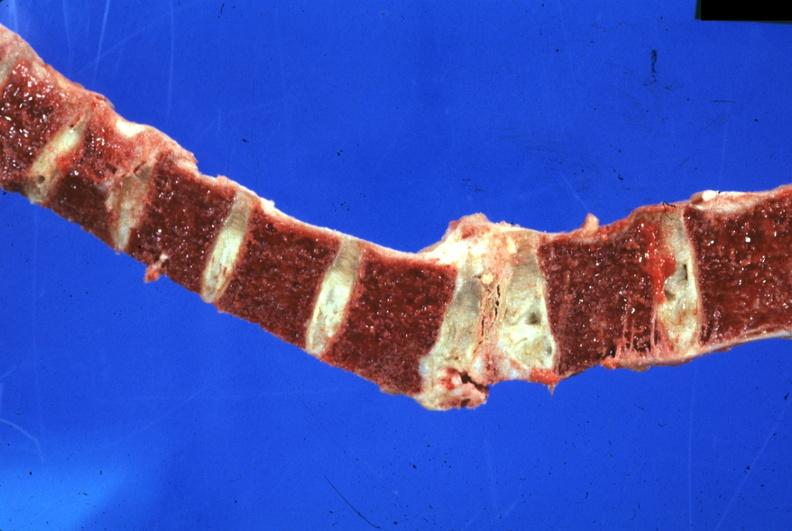what does this image show?
Answer the question using a single word or phrase. Old lesion well shown 